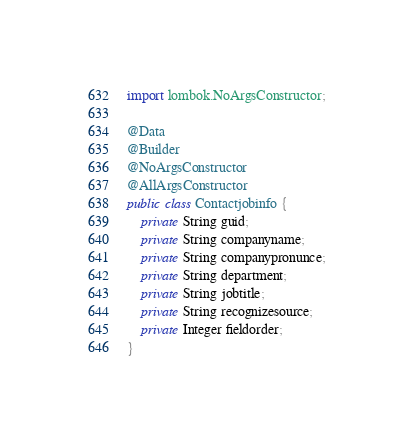<code> <loc_0><loc_0><loc_500><loc_500><_Java_>import lombok.NoArgsConstructor;

@Data
@Builder
@NoArgsConstructor
@AllArgsConstructor
public class Contactjobinfo {
    private String guid;
    private String companyname;
    private String companypronunce;
    private String department;
    private String jobtitle;
    private String recognizesource;
    private Integer fieldorder;
}
</code> 